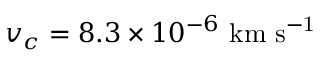Convert formula to latex. <formula><loc_0><loc_0><loc_500><loc_500>v _ { c } = 8 . 3 \times 1 0 ^ { - 6 } \ k m \ s ^ { - 1 }</formula> 